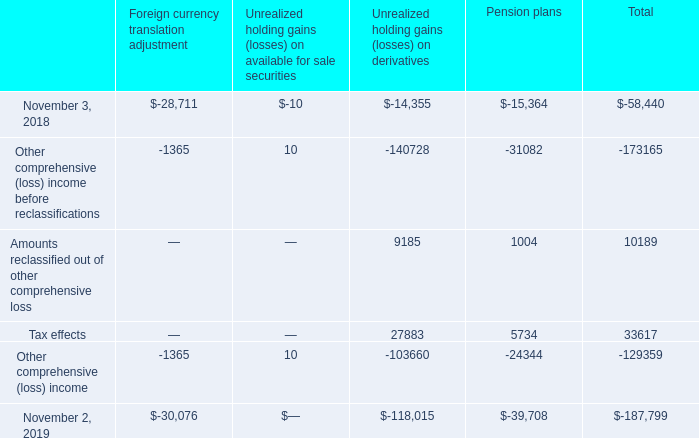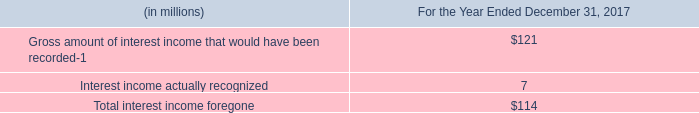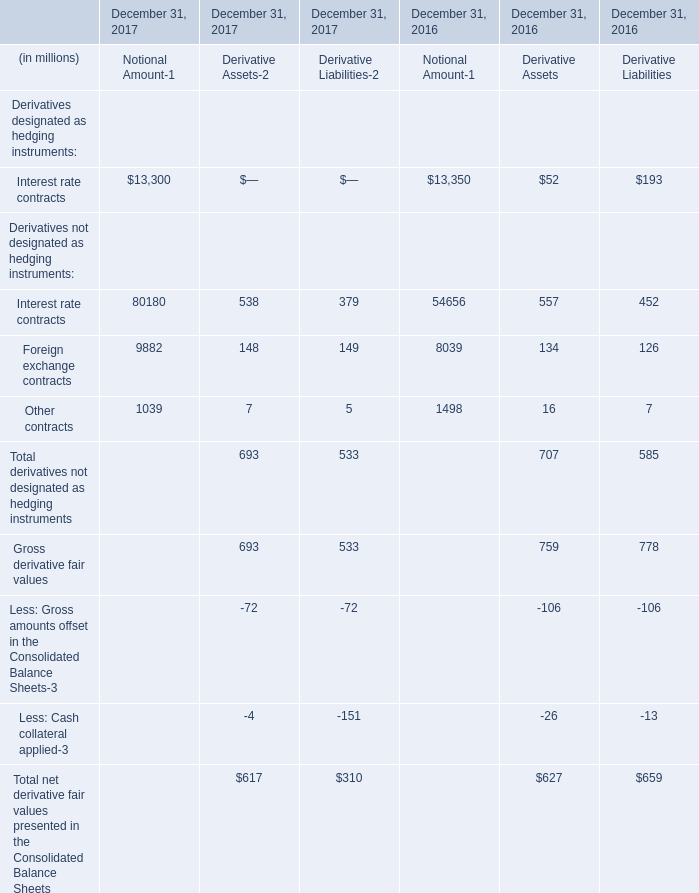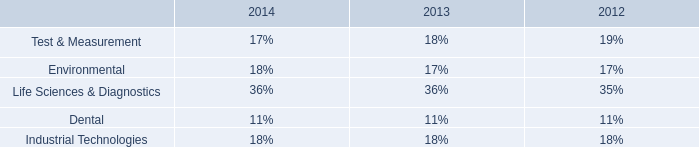What was the average of Interest rate contracts in 2017 for Notional Amount-, Derivative Assets, and Derivative Liabilities ? (in million) 
Computations: (((80180 + 538) + 379) / 3)
Answer: 27032.33333. 